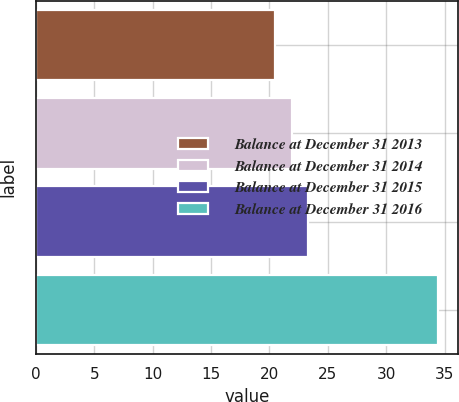<chart> <loc_0><loc_0><loc_500><loc_500><bar_chart><fcel>Balance at December 31 2013<fcel>Balance at December 31 2014<fcel>Balance at December 31 2015<fcel>Balance at December 31 2016<nl><fcel>20.5<fcel>21.9<fcel>23.29<fcel>34.4<nl></chart> 